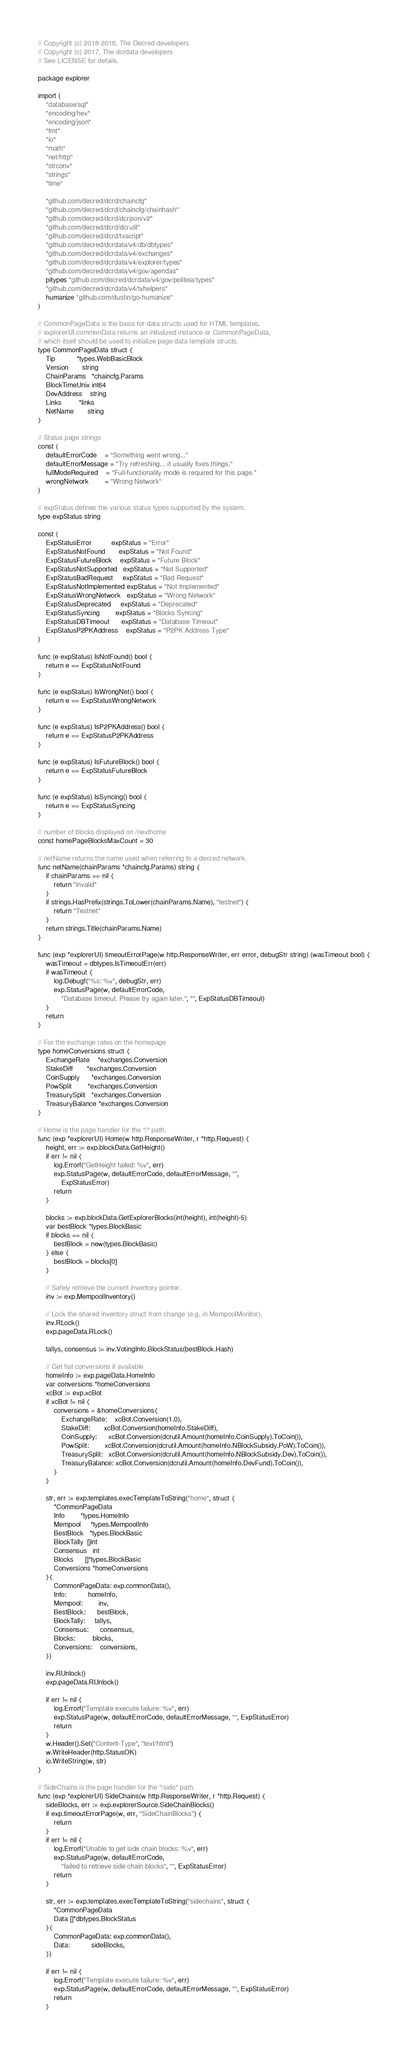Convert code to text. <code><loc_0><loc_0><loc_500><loc_500><_Go_>// Copyright (c) 2018-2019, The Decred developers
// Copyright (c) 2017, The dcrdata developers
// See LICENSE for details.

package explorer

import (
	"database/sql"
	"encoding/hex"
	"encoding/json"
	"fmt"
	"io"
	"math"
	"net/http"
	"strconv"
	"strings"
	"time"

	"github.com/decred/dcrd/chaincfg"
	"github.com/decred/dcrd/chaincfg/chainhash"
	"github.com/decred/dcrd/dcrjson/v2"
	"github.com/decred/dcrd/dcrutil"
	"github.com/decred/dcrd/txscript"
	"github.com/decred/dcrdata/v4/db/dbtypes"
	"github.com/decred/dcrdata/v4/exchanges"
	"github.com/decred/dcrdata/v4/explorer/types"
	"github.com/decred/dcrdata/v4/gov/agendas"
	pitypes "github.com/decred/dcrdata/v4/gov/politeia/types"
	"github.com/decred/dcrdata/v4/txhelpers"
	humanize "github.com/dustin/go-humanize"
)

// CommonPageData is the basis for data structs used for HTML templates.
// explorerUI.commonData returns an initialized instance or CommonPageData,
// which itself should be used to initialize page data template structs.
type CommonPageData struct {
	Tip           *types.WebBasicBlock
	Version       string
	ChainParams   *chaincfg.Params
	BlockTimeUnix int64
	DevAddress    string
	Links         *links
	NetName       string
}

// Status page strings
const (
	defaultErrorCode    = "Something went wrong..."
	defaultErrorMessage = "Try refreshing... it usually fixes things."
	fullModeRequired    = "Full-functionality mode is required for this page."
	wrongNetwork        = "Wrong Network"
)

// expStatus defines the various status types supported by the system.
type expStatus string

const (
	ExpStatusError          expStatus = "Error"
	ExpStatusNotFound       expStatus = "Not Found"
	ExpStatusFutureBlock    expStatus = "Future Block"
	ExpStatusNotSupported   expStatus = "Not Supported"
	ExpStatusBadRequest     expStatus = "Bad Request"
	ExpStatusNotImplemented expStatus = "Not Implemented"
	ExpStatusWrongNetwork   expStatus = "Wrong Network"
	ExpStatusDeprecated     expStatus = "Deprecated"
	ExpStatusSyncing        expStatus = "Blocks Syncing"
	ExpStatusDBTimeout      expStatus = "Database Timeout"
	ExpStatusP2PKAddress    expStatus = "P2PK Address Type"
)

func (e expStatus) IsNotFound() bool {
	return e == ExpStatusNotFound
}

func (e expStatus) IsWrongNet() bool {
	return e == ExpStatusWrongNetwork
}

func (e expStatus) IsP2PKAddress() bool {
	return e == ExpStatusP2PKAddress
}

func (e expStatus) IsFutureBlock() bool {
	return e == ExpStatusFutureBlock
}

func (e expStatus) IsSyncing() bool {
	return e == ExpStatusSyncing
}

// number of blocks displayed on /nexthome
const homePageBlocksMaxCount = 30

// netName returns the name used when referring to a decred network.
func netName(chainParams *chaincfg.Params) string {
	if chainParams == nil {
		return "invalid"
	}
	if strings.HasPrefix(strings.ToLower(chainParams.Name), "testnet") {
		return "Testnet"
	}
	return strings.Title(chainParams.Name)
}

func (exp *explorerUI) timeoutErrorPage(w http.ResponseWriter, err error, debugStr string) (wasTimeout bool) {
	wasTimeout = dbtypes.IsTimeoutErr(err)
	if wasTimeout {
		log.Debugf("%s: %v", debugStr, err)
		exp.StatusPage(w, defaultErrorCode,
			"Database timeout. Please try again later.", "", ExpStatusDBTimeout)
	}
	return
}

// For the exchange rates on the homepage
type homeConversions struct {
	ExchangeRate    *exchanges.Conversion
	StakeDiff       *exchanges.Conversion
	CoinSupply      *exchanges.Conversion
	PowSplit        *exchanges.Conversion
	TreasurySplit   *exchanges.Conversion
	TreasuryBalance *exchanges.Conversion
}

// Home is the page handler for the "/" path.
func (exp *explorerUI) Home(w http.ResponseWriter, r *http.Request) {
	height, err := exp.blockData.GetHeight()
	if err != nil {
		log.Errorf("GetHeight failed: %v", err)
		exp.StatusPage(w, defaultErrorCode, defaultErrorMessage, "",
			ExpStatusError)
		return
	}

	blocks := exp.blockData.GetExplorerBlocks(int(height), int(height)-5)
	var bestBlock *types.BlockBasic
	if blocks == nil {
		bestBlock = new(types.BlockBasic)
	} else {
		bestBlock = blocks[0]
	}

	// Safely retrieve the current inventory pointer.
	inv := exp.MempoolInventory()

	// Lock the shared inventory struct from change (e.g. in MempoolMonitor).
	inv.RLock()
	exp.pageData.RLock()

	tallys, consensus := inv.VotingInfo.BlockStatus(bestBlock.Hash)

	// Get fiat conversions if available
	homeInfo := exp.pageData.HomeInfo
	var conversions *homeConversions
	xcBot := exp.xcBot
	if xcBot != nil {
		conversions = &homeConversions{
			ExchangeRate:    xcBot.Conversion(1.0),
			StakeDiff:       xcBot.Conversion(homeInfo.StakeDiff),
			CoinSupply:      xcBot.Conversion(dcrutil.Amount(homeInfo.CoinSupply).ToCoin()),
			PowSplit:        xcBot.Conversion(dcrutil.Amount(homeInfo.NBlockSubsidy.PoW).ToCoin()),
			TreasurySplit:   xcBot.Conversion(dcrutil.Amount(homeInfo.NBlockSubsidy.Dev).ToCoin()),
			TreasuryBalance: xcBot.Conversion(dcrutil.Amount(homeInfo.DevFund).ToCoin()),
		}
	}

	str, err := exp.templates.execTemplateToString("home", struct {
		*CommonPageData
		Info        *types.HomeInfo
		Mempool     *types.MempoolInfo
		BestBlock   *types.BlockBasic
		BlockTally  []int
		Consensus   int
		Blocks      []*types.BlockBasic
		Conversions *homeConversions
	}{
		CommonPageData: exp.commonData(),
		Info:           homeInfo,
		Mempool:        inv,
		BestBlock:      bestBlock,
		BlockTally:     tallys,
		Consensus:      consensus,
		Blocks:         blocks,
		Conversions:    conversions,
	})

	inv.RUnlock()
	exp.pageData.RUnlock()

	if err != nil {
		log.Errorf("Template execute failure: %v", err)
		exp.StatusPage(w, defaultErrorCode, defaultErrorMessage, "", ExpStatusError)
		return
	}
	w.Header().Set("Content-Type", "text/html")
	w.WriteHeader(http.StatusOK)
	io.WriteString(w, str)
}

// SideChains is the page handler for the "/side" path.
func (exp *explorerUI) SideChains(w http.ResponseWriter, r *http.Request) {
	sideBlocks, err := exp.explorerSource.SideChainBlocks()
	if exp.timeoutErrorPage(w, err, "SideChainBlocks") {
		return
	}
	if err != nil {
		log.Errorf("Unable to get side chain blocks: %v", err)
		exp.StatusPage(w, defaultErrorCode,
			"failed to retrieve side chain blocks", "", ExpStatusError)
		return
	}

	str, err := exp.templates.execTemplateToString("sidechains", struct {
		*CommonPageData
		Data []*dbtypes.BlockStatus
	}{
		CommonPageData: exp.commonData(),
		Data:           sideBlocks,
	})

	if err != nil {
		log.Errorf("Template execute failure: %v", err)
		exp.StatusPage(w, defaultErrorCode, defaultErrorMessage, "", ExpStatusError)
		return
	}</code> 